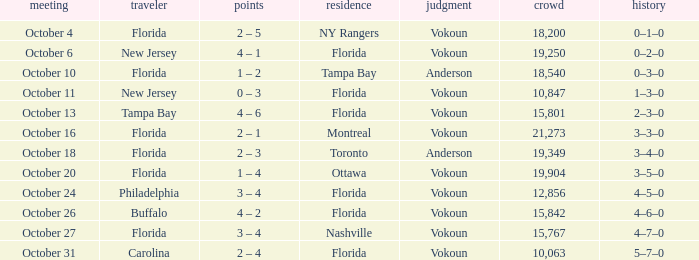What was the score on October 31? 2 – 4. 